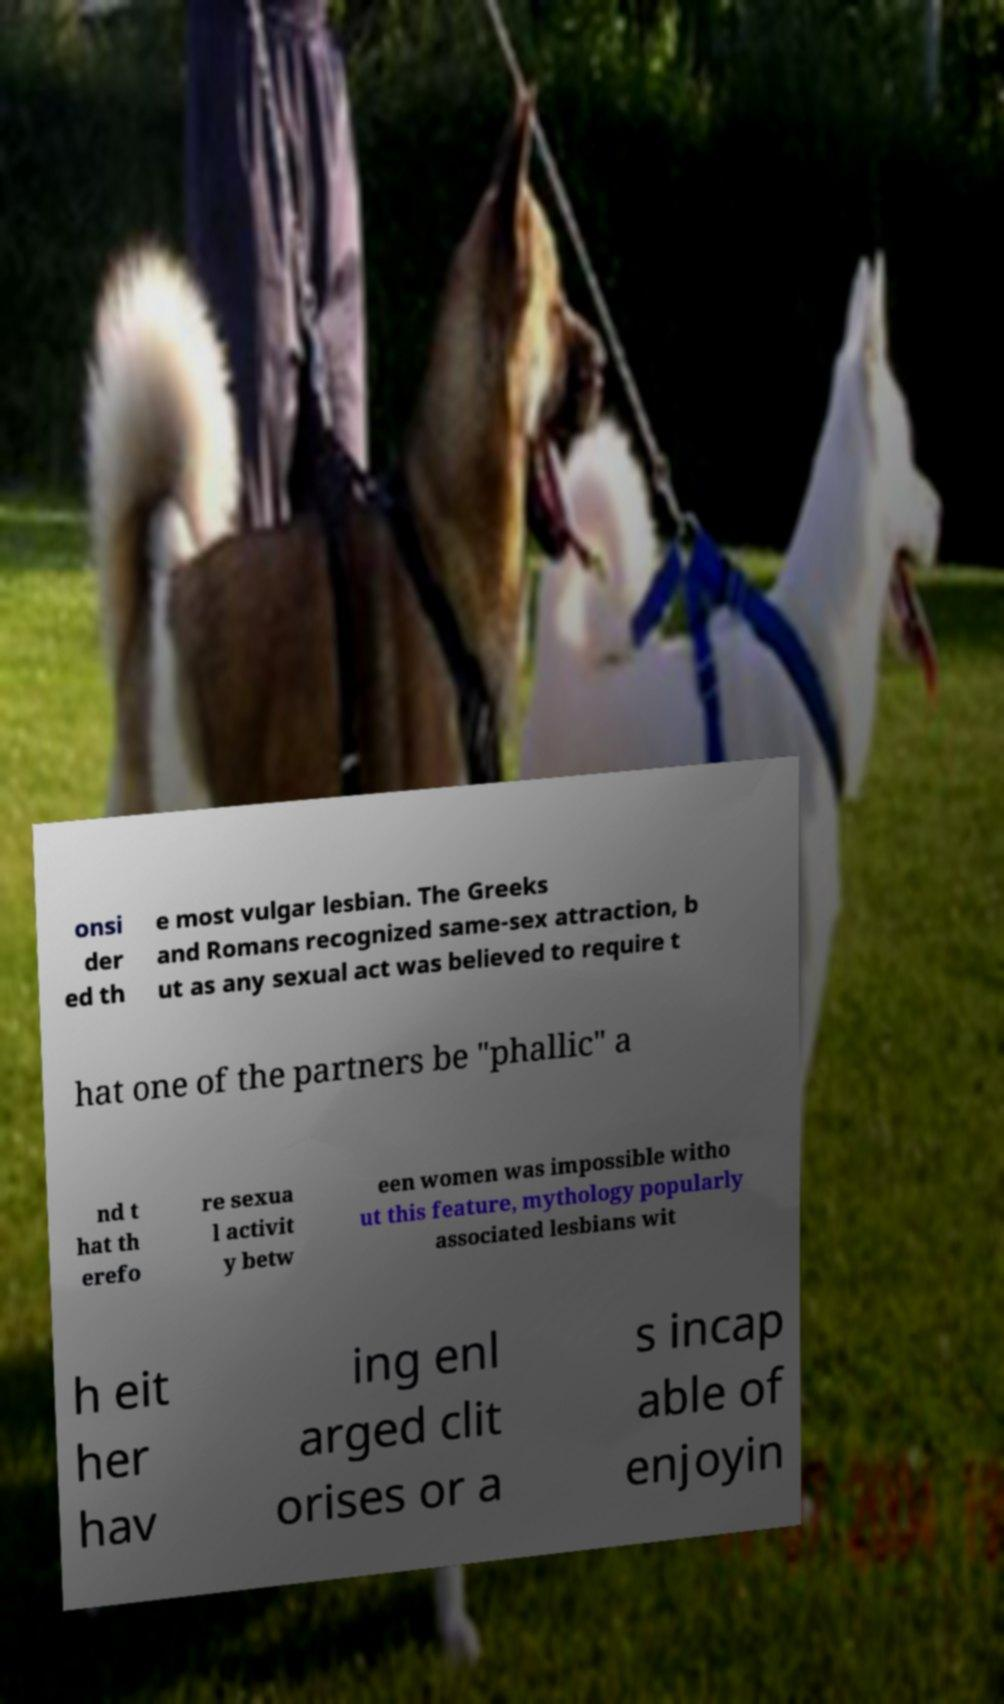For documentation purposes, I need the text within this image transcribed. Could you provide that? onsi der ed th e most vulgar lesbian. The Greeks and Romans recognized same-sex attraction, b ut as any sexual act was believed to require t hat one of the partners be "phallic" a nd t hat th erefo re sexua l activit y betw een women was impossible witho ut this feature, mythology popularly associated lesbians wit h eit her hav ing enl arged clit orises or a s incap able of enjoyin 